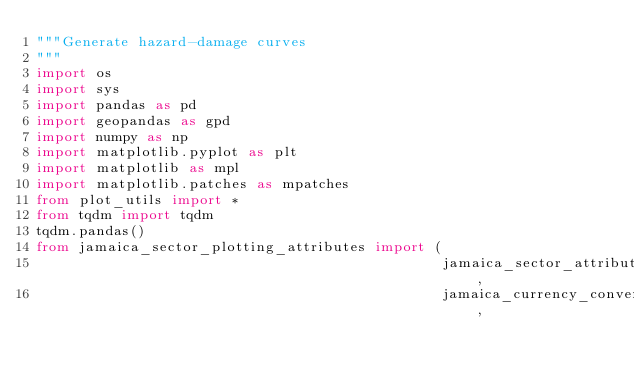<code> <loc_0><loc_0><loc_500><loc_500><_Python_>"""Generate hazard-damage curves
"""
import os
import sys
import pandas as pd
import geopandas as gpd
import numpy as np
import matplotlib.pyplot as plt
import matplotlib as mpl
import matplotlib.patches as mpatches
from plot_utils import *
from tqdm import tqdm
tqdm.pandas()
from jamaica_sector_plotting_attributes import (
                                                jamaica_sector_attributes, 
                                                jamaica_currency_conversion, </code> 